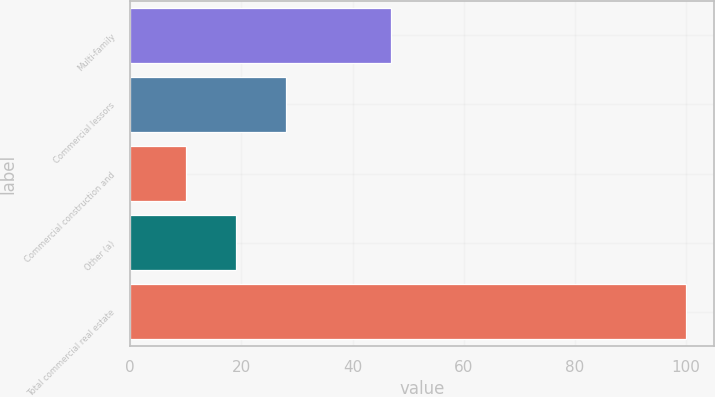<chart> <loc_0><loc_0><loc_500><loc_500><bar_chart><fcel>Multi-family<fcel>Commercial lessors<fcel>Commercial construction and<fcel>Other (a)<fcel>Total commercial real estate<nl><fcel>47<fcel>28<fcel>10<fcel>19<fcel>100<nl></chart> 